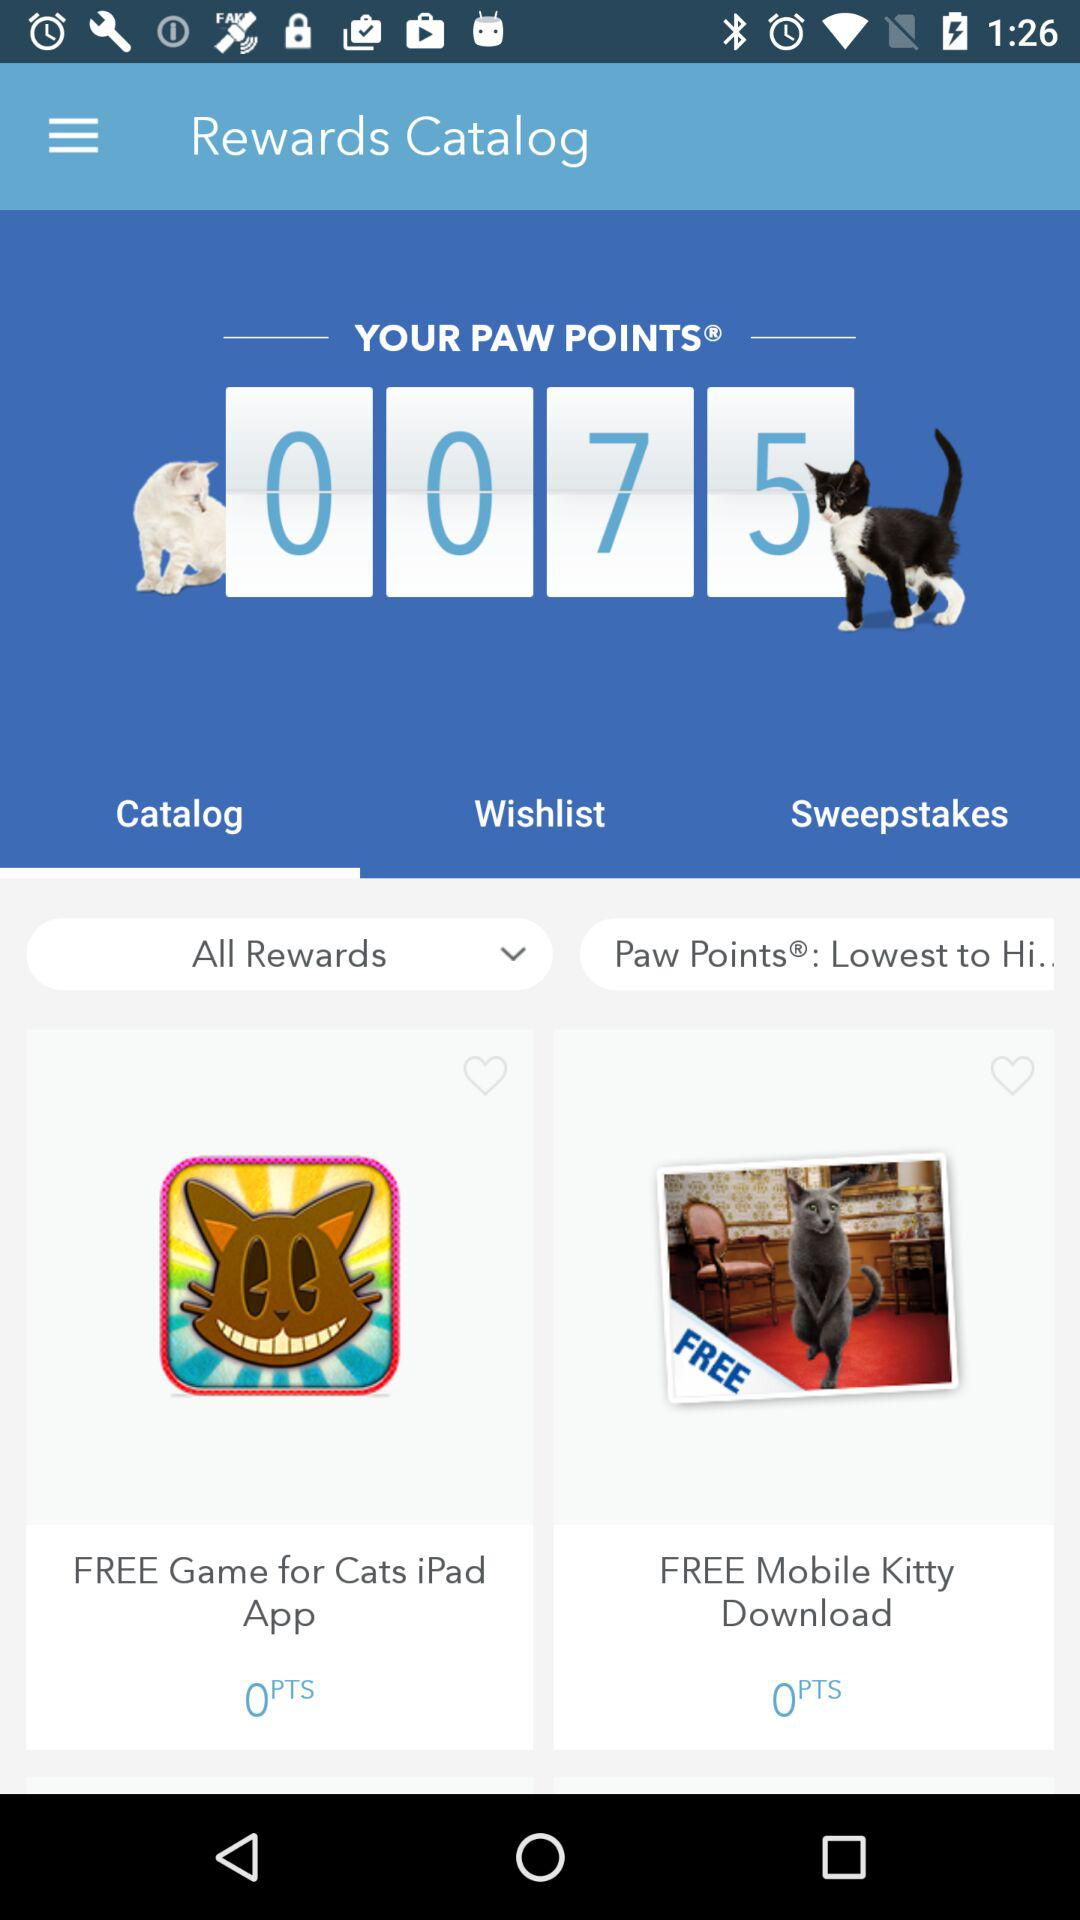Is "Mobile Kitty" downloading free or paid?
Answer the question using a single word or phrase. It is free. 